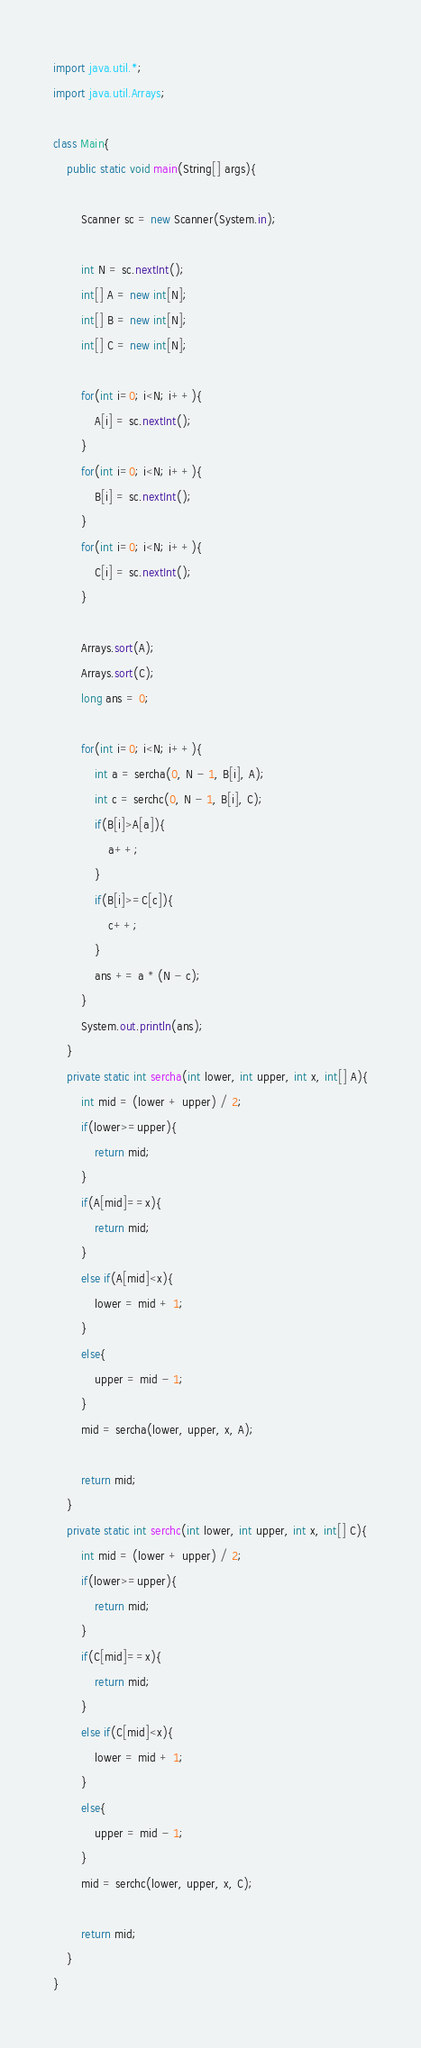Convert code to text. <code><loc_0><loc_0><loc_500><loc_500><_Java_>import java.util.*;
import java.util.Arrays;

class Main{
    public static void main(String[] args){
        
        Scanner sc = new Scanner(System.in);

        int N = sc.nextInt();
        int[] A = new int[N];
        int[] B = new int[N];
        int[] C = new int[N];

        for(int i=0; i<N; i++){
            A[i] = sc.nextInt();
        }
        for(int i=0; i<N; i++){
            B[i] = sc.nextInt();
        }
        for(int i=0; i<N; i++){
            C[i] = sc.nextInt();
        }

        Arrays.sort(A);
        Arrays.sort(C);
        long ans = 0;

        for(int i=0; i<N; i++){
            int a = sercha(0, N - 1, B[i], A);
            int c = serchc(0, N - 1, B[i], C);
            if(B[i]>A[a]){
                a++;
            }
            if(B[i]>=C[c]){
                c++;
            }
            ans += a * (N - c);
        }
        System.out.println(ans);
    }
    private static int sercha(int lower, int upper, int x, int[] A){
        int mid = (lower + upper) / 2;
        if(lower>=upper){
            return mid;
        }
        if(A[mid]==x){
            return mid;
        }
        else if(A[mid]<x){
            lower = mid + 1;
        }
        else{
            upper = mid - 1;
        }
        mid = sercha(lower, upper, x, A);

        return mid;
    }
    private static int serchc(int lower, int upper, int x, int[] C){
        int mid = (lower + upper) / 2;
        if(lower>=upper){
            return mid;
        }
        if(C[mid]==x){
            return mid;
        }
        else if(C[mid]<x){
            lower = mid + 1;
        }
        else{
            upper = mid - 1;
        }
        mid = serchc(lower, upper, x, C);

        return mid;
    }
}</code> 